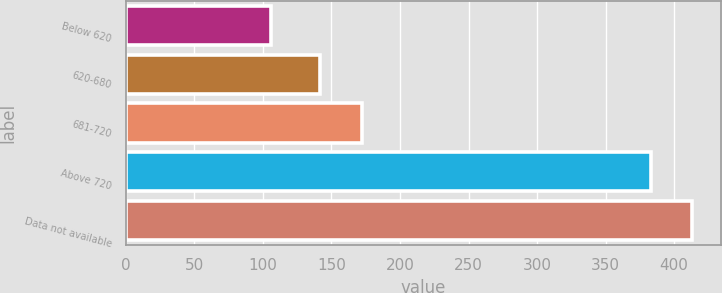Convert chart to OTSL. <chart><loc_0><loc_0><loc_500><loc_500><bar_chart><fcel>Below 620<fcel>620-680<fcel>681-720<fcel>Above 720<fcel>Data not available<nl><fcel>106<fcel>142<fcel>172.3<fcel>383<fcel>413.3<nl></chart> 